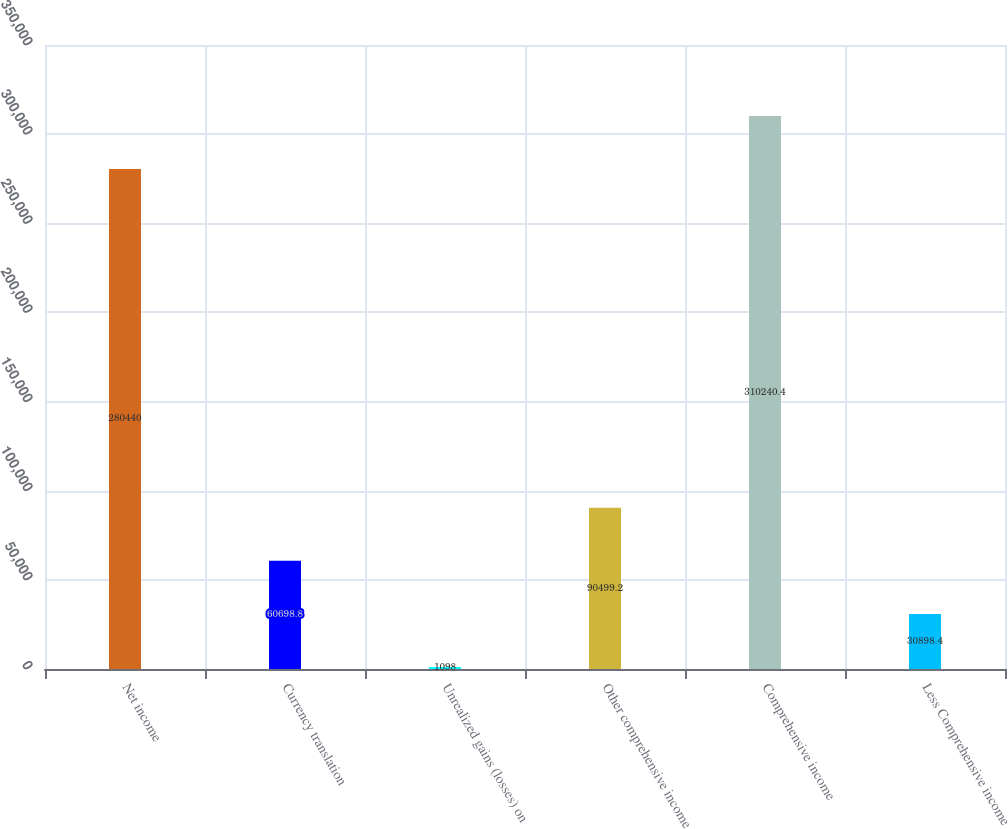Convert chart to OTSL. <chart><loc_0><loc_0><loc_500><loc_500><bar_chart><fcel>Net income<fcel>Currency translation<fcel>Unrealized gains (losses) on<fcel>Other comprehensive income<fcel>Comprehensive income<fcel>Less Comprehensive income<nl><fcel>280440<fcel>60698.8<fcel>1098<fcel>90499.2<fcel>310240<fcel>30898.4<nl></chart> 